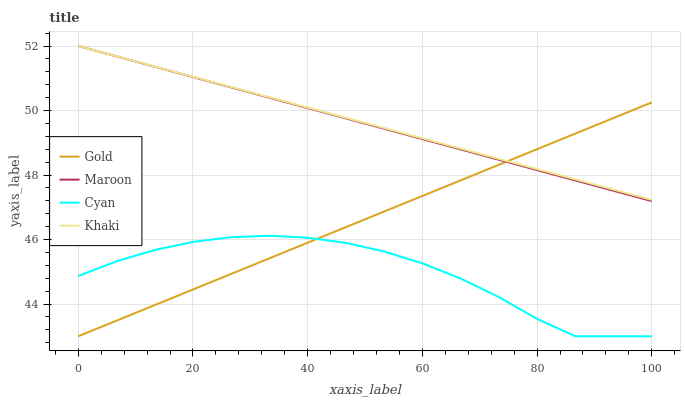Does Cyan have the minimum area under the curve?
Answer yes or no. Yes. Does Khaki have the maximum area under the curve?
Answer yes or no. Yes. Does Maroon have the minimum area under the curve?
Answer yes or no. No. Does Maroon have the maximum area under the curve?
Answer yes or no. No. Is Khaki the smoothest?
Answer yes or no. Yes. Is Cyan the roughest?
Answer yes or no. Yes. Is Maroon the smoothest?
Answer yes or no. No. Is Maroon the roughest?
Answer yes or no. No. Does Cyan have the lowest value?
Answer yes or no. Yes. Does Maroon have the lowest value?
Answer yes or no. No. Does Maroon have the highest value?
Answer yes or no. Yes. Does Gold have the highest value?
Answer yes or no. No. Is Cyan less than Khaki?
Answer yes or no. Yes. Is Maroon greater than Cyan?
Answer yes or no. Yes. Does Khaki intersect Gold?
Answer yes or no. Yes. Is Khaki less than Gold?
Answer yes or no. No. Is Khaki greater than Gold?
Answer yes or no. No. Does Cyan intersect Khaki?
Answer yes or no. No. 